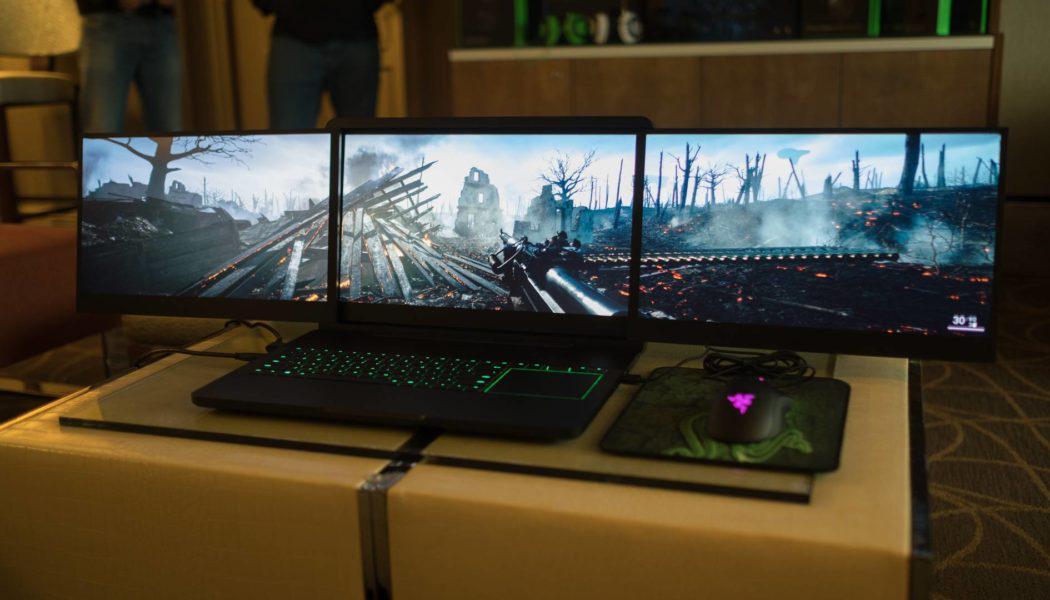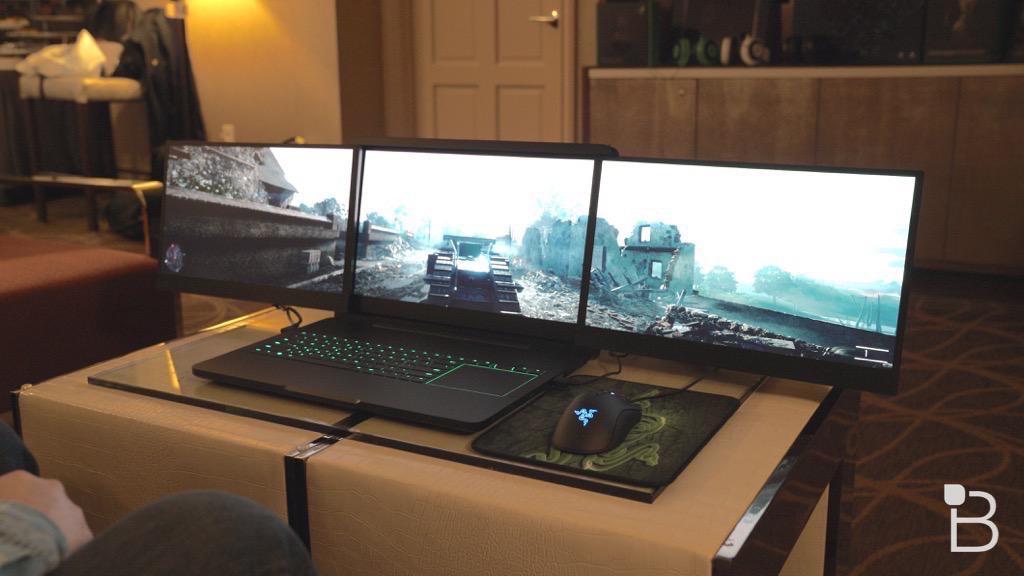The first image is the image on the left, the second image is the image on the right. For the images displayed, is the sentence "Each image shows a mostly head-on view of a triple-display laptop on a brownish desk, projecting a video game scene." factually correct? Answer yes or no. Yes. The first image is the image on the left, the second image is the image on the right. Given the left and right images, does the statement "The computer mouse in one of the image has a purple triangle light on it." hold true? Answer yes or no. Yes. 